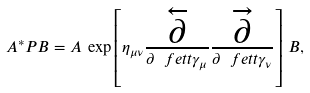Convert formula to latex. <formula><loc_0><loc_0><loc_500><loc_500>A ^ { * } P B = A \, \exp \left [ \eta _ { \mu \nu } \frac { \overleftarrow { \partial } } { \partial \ f e t t { \gamma } _ { \mu } } \frac { \overrightarrow { \partial } } { \partial \ f e t t { \gamma } _ { \nu } } \right ] \, B ,</formula> 